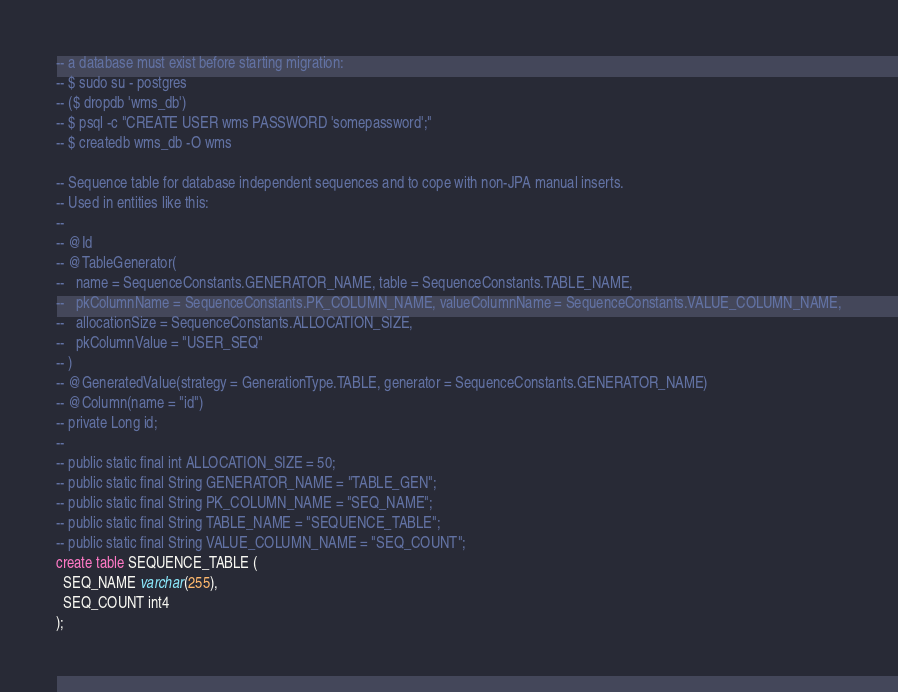<code> <loc_0><loc_0><loc_500><loc_500><_SQL_>-- a database must exist before starting migration:
-- $ sudo su - postgres
-- ($ dropdb 'wms_db')
-- $ psql -c "CREATE USER wms PASSWORD 'somepassword';"
-- $ createdb wms_db -O wms

-- Sequence table for database independent sequences and to cope with non-JPA manual inserts.
-- Used in entities like this:
--
-- @Id
-- @TableGenerator(
--   name = SequenceConstants.GENERATOR_NAME, table = SequenceConstants.TABLE_NAME,
--   pkColumnName = SequenceConstants.PK_COLUMN_NAME, valueColumnName = SequenceConstants.VALUE_COLUMN_NAME,
--   allocationSize = SequenceConstants.ALLOCATION_SIZE,
--   pkColumnValue = "USER_SEQ"
-- )
-- @GeneratedValue(strategy = GenerationType.TABLE, generator = SequenceConstants.GENERATOR_NAME)
-- @Column(name = "id")
-- private Long id;
--
-- public static final int ALLOCATION_SIZE = 50;
-- public static final String GENERATOR_NAME = "TABLE_GEN";
-- public static final String PK_COLUMN_NAME = "SEQ_NAME";
-- public static final String TABLE_NAME = "SEQUENCE_TABLE";
-- public static final String VALUE_COLUMN_NAME = "SEQ_COUNT";
create table SEQUENCE_TABLE (
  SEQ_NAME varchar(255),
  SEQ_COUNT int4 
);</code> 